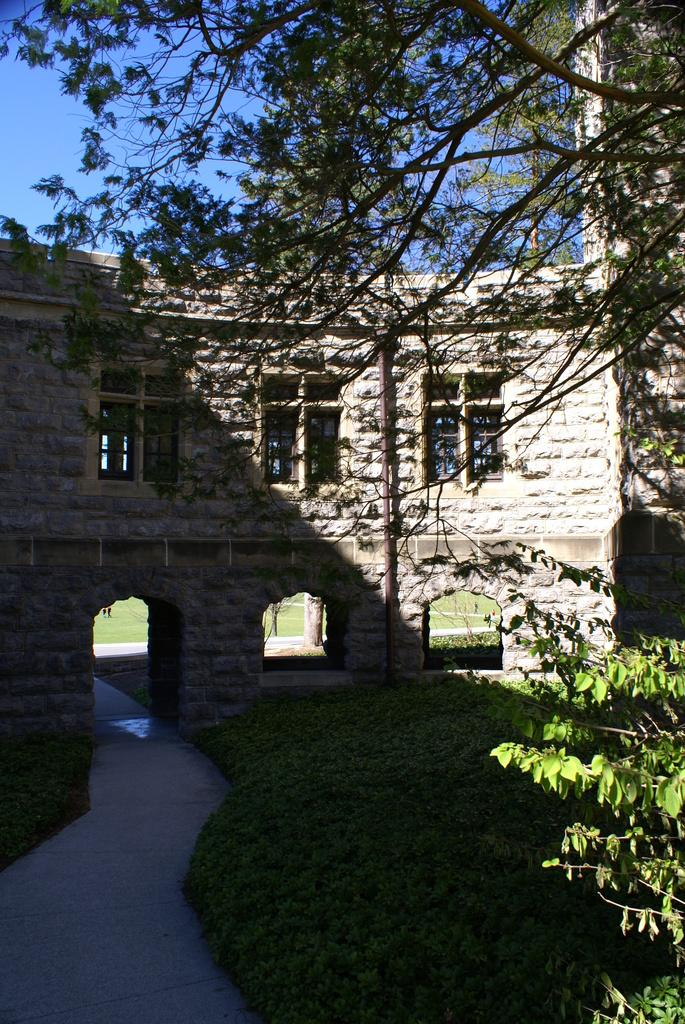What can be seen in the center of the image? The sky is visible in the center of the image. What type of vegetation is present in the image? There are branches with leaves and plants in the image. What is the ground made of in the image? Grass is present in the image. Are there any structures visible in the image? Yes, there is at least one building in the image. What architectural features can be seen on the building? Windows and pillars with arches are present in the image. Can you see your father at the seashore in the image? There is no seashore or father present in the image. What type of waves can be seen in the image? There are no waves present in the image. 